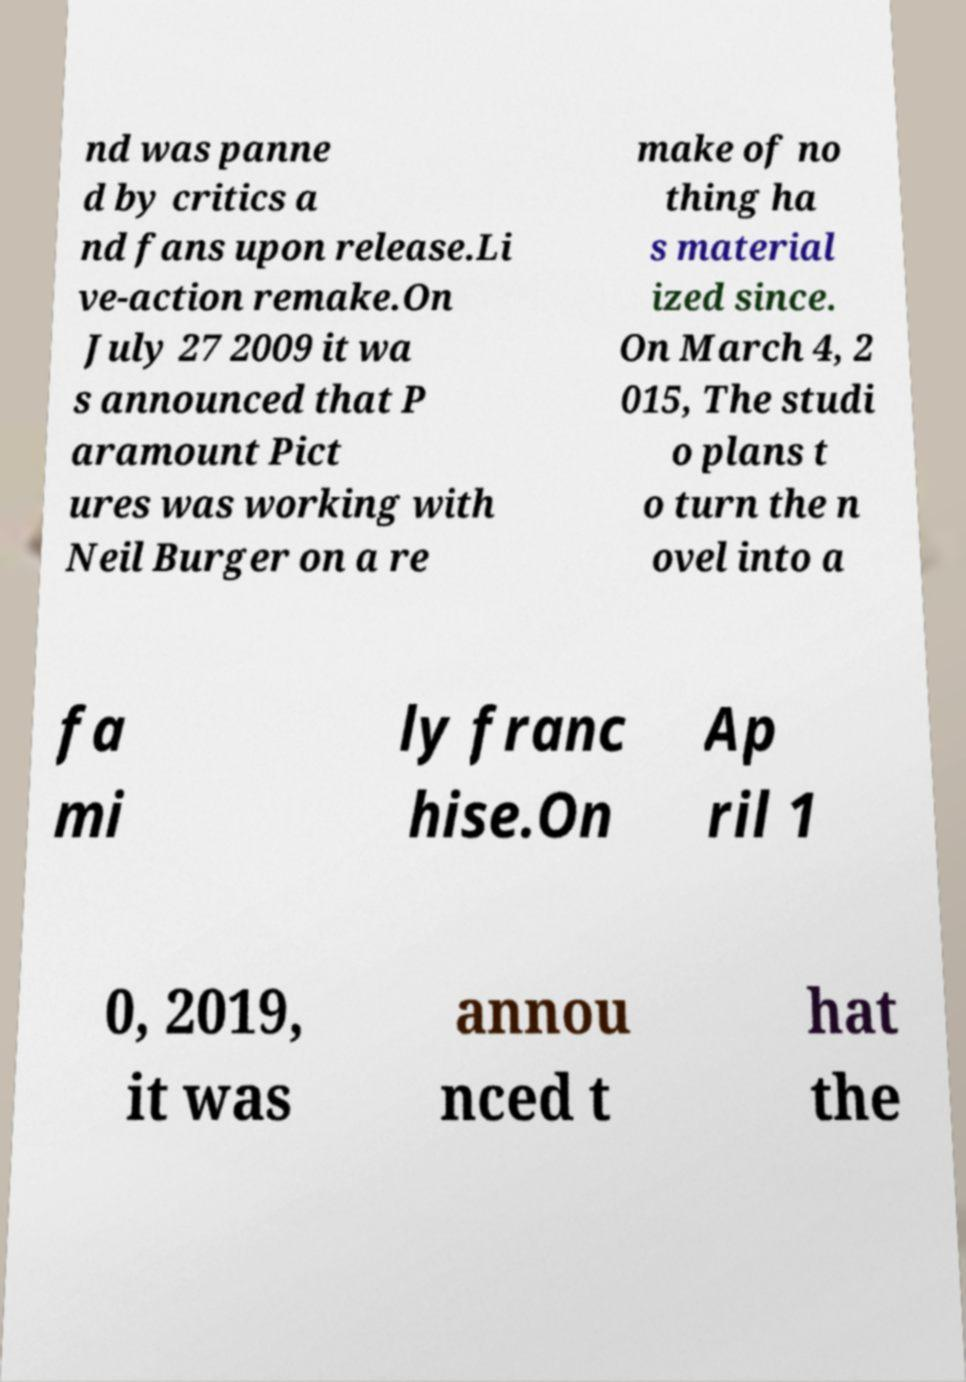Could you assist in decoding the text presented in this image and type it out clearly? nd was panne d by critics a nd fans upon release.Li ve-action remake.On July 27 2009 it wa s announced that P aramount Pict ures was working with Neil Burger on a re make of no thing ha s material ized since. On March 4, 2 015, The studi o plans t o turn the n ovel into a fa mi ly franc hise.On Ap ril 1 0, 2019, it was annou nced t hat the 